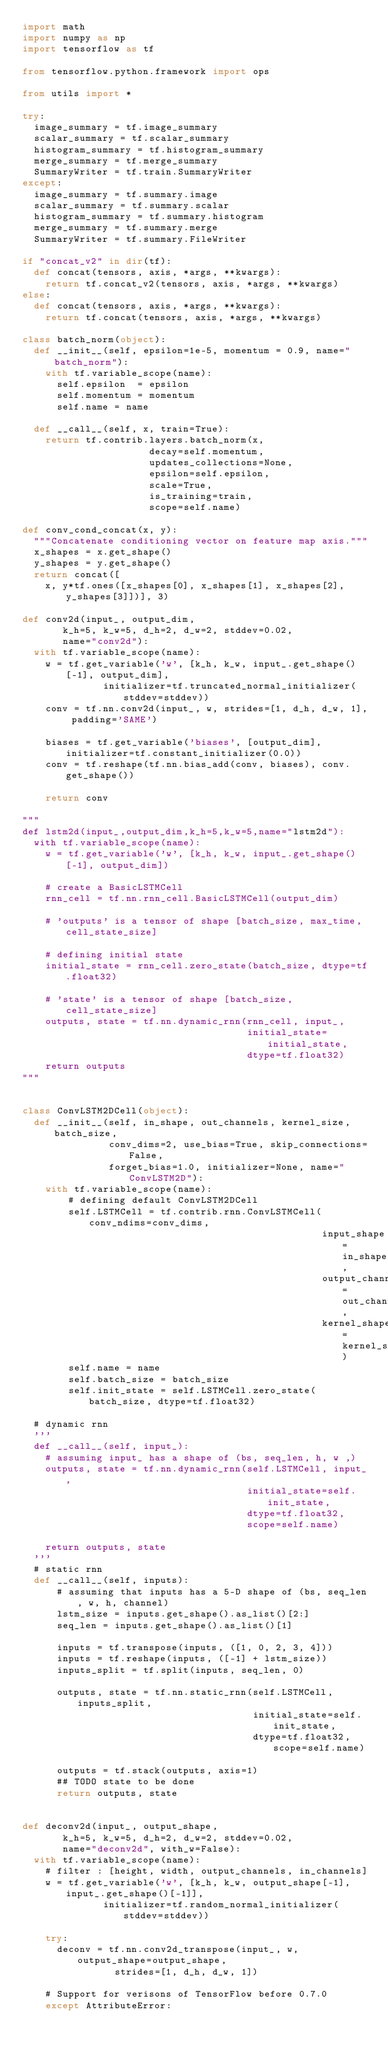Convert code to text. <code><loc_0><loc_0><loc_500><loc_500><_Python_>import math
import numpy as np
import tensorflow as tf

from tensorflow.python.framework import ops

from utils import *

try:
  image_summary = tf.image_summary
  scalar_summary = tf.scalar_summary
  histogram_summary = tf.histogram_summary
  merge_summary = tf.merge_summary
  SummaryWriter = tf.train.SummaryWriter
except:
  image_summary = tf.summary.image
  scalar_summary = tf.summary.scalar
  histogram_summary = tf.summary.histogram
  merge_summary = tf.summary.merge
  SummaryWriter = tf.summary.FileWriter

if "concat_v2" in dir(tf):
  def concat(tensors, axis, *args, **kwargs):
    return tf.concat_v2(tensors, axis, *args, **kwargs)
else:
  def concat(tensors, axis, *args, **kwargs):
    return tf.concat(tensors, axis, *args, **kwargs)

class batch_norm(object):
  def __init__(self, epsilon=1e-5, momentum = 0.9, name="batch_norm"):
    with tf.variable_scope(name):
      self.epsilon  = epsilon
      self.momentum = momentum
      self.name = name

  def __call__(self, x, train=True):
    return tf.contrib.layers.batch_norm(x,
                      decay=self.momentum,
                      updates_collections=None,
                      epsilon=self.epsilon,
                      scale=True,
                      is_training=train,
                      scope=self.name)

def conv_cond_concat(x, y):
  """Concatenate conditioning vector on feature map axis."""
  x_shapes = x.get_shape()
  y_shapes = y.get_shape()
  return concat([
    x, y*tf.ones([x_shapes[0], x_shapes[1], x_shapes[2], y_shapes[3]])], 3)

def conv2d(input_, output_dim,
       k_h=5, k_w=5, d_h=2, d_w=2, stddev=0.02,
       name="conv2d"):
  with tf.variable_scope(name):
    w = tf.get_variable('w', [k_h, k_w, input_.get_shape()[-1], output_dim],
              initializer=tf.truncated_normal_initializer(stddev=stddev))
    conv = tf.nn.conv2d(input_, w, strides=[1, d_h, d_w, 1], padding='SAME')

    biases = tf.get_variable('biases', [output_dim], initializer=tf.constant_initializer(0.0))
    conv = tf.reshape(tf.nn.bias_add(conv, biases), conv.get_shape())

    return conv

"""
def lstm2d(input_,output_dim,k_h=5,k_w=5,name="lstm2d"):
  with tf.variable_scope(name):
    w = tf.get_variable('w', [k_h, k_w, input_.get_shape()[-1], output_dim])

    # create a BasicLSTMCell
    rnn_cell = tf.nn.rnn_cell.BasicLSTMCell(output_dim)

    # 'outputs' is a tensor of shape [batch_size, max_time, cell_state_size]

    # defining initial state
    initial_state = rnn_cell.zero_state(batch_size, dtype=tf.float32)

    # 'state' is a tensor of shape [batch_size, cell_state_size]
    outputs, state = tf.nn.dynamic_rnn(rnn_cell, input_,
                                       initial_state=initial_state,
                                       dtype=tf.float32)
    return outputs
"""


class ConvLSTM2DCell(object):
  def __init__(self, in_shape, out_channels, kernel_size, batch_size,
               conv_dims=2, use_bias=True, skip_connections=False,
               forget_bias=1.0, initializer=None, name="ConvLSTM2D"):
    with tf.variable_scope(name):
        # defining default ConvLSTM2DCell
        self.LSTMCell = tf.contrib.rnn.ConvLSTMCell(conv_ndims=conv_dims,
                                                    input_shape=in_shape,
                                                    output_channels=out_channels,
                                                    kernel_shape=kernel_size)
        self.name = name
        self.batch_size = batch_size
        self.init_state = self.LSTMCell.zero_state(batch_size, dtype=tf.float32)

  # dynamic rnn
  '''
  def __call__(self, input_):
    # assuming input_ has a shape of (bs, seq_len, h, w ,)
    outputs, state = tf.nn.dynamic_rnn(self.LSTMCell, input_,
                                       initial_state=self.init_state,
                                       dtype=tf.float32,
                                       scope=self.name)

    return outputs, state
  '''
  # static rnn
  def __call__(self, inputs):
      # assuming that inputs has a 5-D shape of (bs, seq_len, w, h, channel)
      lstm_size = inputs.get_shape().as_list()[2:]
      seq_len = inputs.get_shape().as_list()[1]

      inputs = tf.transpose(inputs, ([1, 0, 2, 3, 4]))
      inputs = tf.reshape(inputs, ([-1] + lstm_size))
      inputs_split = tf.split(inputs, seq_len, 0)

      outputs, state = tf.nn.static_rnn(self.LSTMCell, inputs_split,
                                        initial_state=self.init_state,
                                        dtype=tf.float32, scope=self.name)

      outputs = tf.stack(outputs, axis=1)
      ## TODO state to be done
      return outputs, state


def deconv2d(input_, output_shape,
       k_h=5, k_w=5, d_h=2, d_w=2, stddev=0.02,
       name="deconv2d", with_w=False):
  with tf.variable_scope(name):
    # filter : [height, width, output_channels, in_channels]
    w = tf.get_variable('w', [k_h, k_w, output_shape[-1], input_.get_shape()[-1]],
              initializer=tf.random_normal_initializer(stddev=stddev))

    try:
      deconv = tf.nn.conv2d_transpose(input_, w, output_shape=output_shape,
                strides=[1, d_h, d_w, 1])

    # Support for verisons of TensorFlow before 0.7.0
    except AttributeError:</code> 